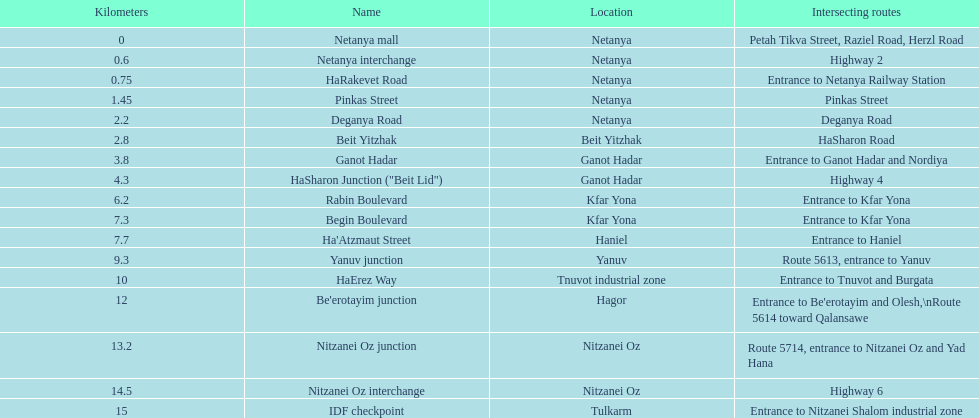What is the place that follows kfar yona? Haniel. 